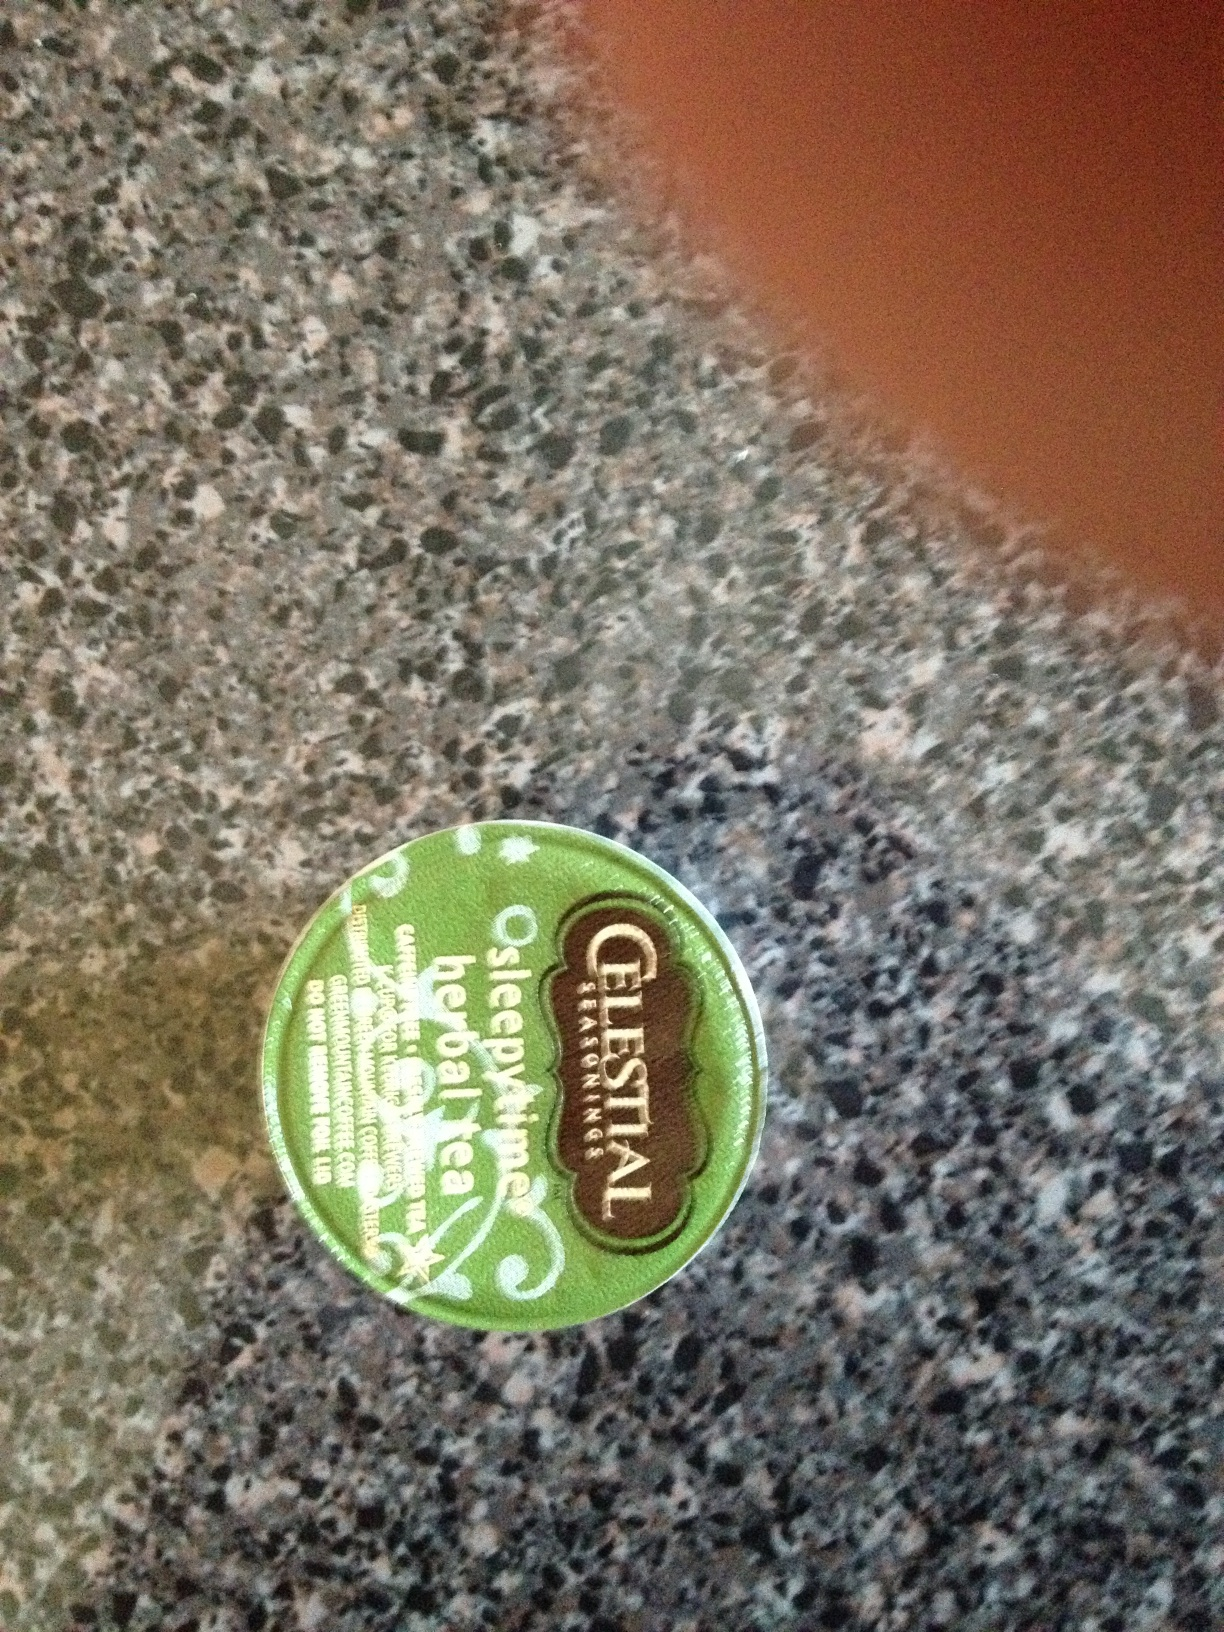Can you please tell me what kind of tea or coffee this is? The image shows a container of 'Celestial Seasonings Sleepytime Herbal Tea.' It is a popular blend of calming herbs including chamomile, spearmint, and lemongrass, typically consumed in the evening to aid relaxation before sleep. 